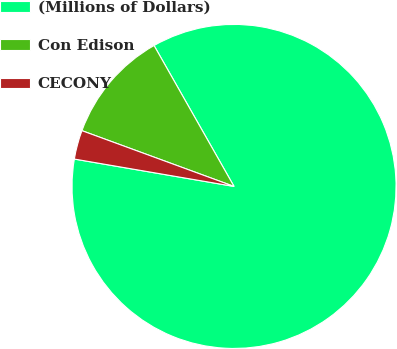Convert chart. <chart><loc_0><loc_0><loc_500><loc_500><pie_chart><fcel>(Millions of Dollars)<fcel>Con Edison<fcel>CECONY<nl><fcel>85.92%<fcel>11.19%<fcel>2.89%<nl></chart> 